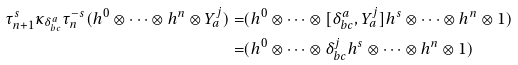Convert formula to latex. <formula><loc_0><loc_0><loc_500><loc_500>\tau _ { n + 1 } ^ { s } \kappa _ { \delta _ { b c } ^ { a } } \tau _ { n } ^ { - s } ( h ^ { 0 } \otimes \cdots \otimes h ^ { n } \otimes Y _ { a } ^ { j } ) = & ( h ^ { 0 } \otimes \cdots \otimes [ \delta _ { b c } ^ { a } , Y _ { a } ^ { j } ] h ^ { s } \otimes \cdots \otimes h ^ { n } \otimes 1 ) \\ = & ( h ^ { 0 } \otimes \cdots \otimes \delta _ { b c } ^ { j } h ^ { s } \otimes \cdots \otimes h ^ { n } \otimes 1 )</formula> 